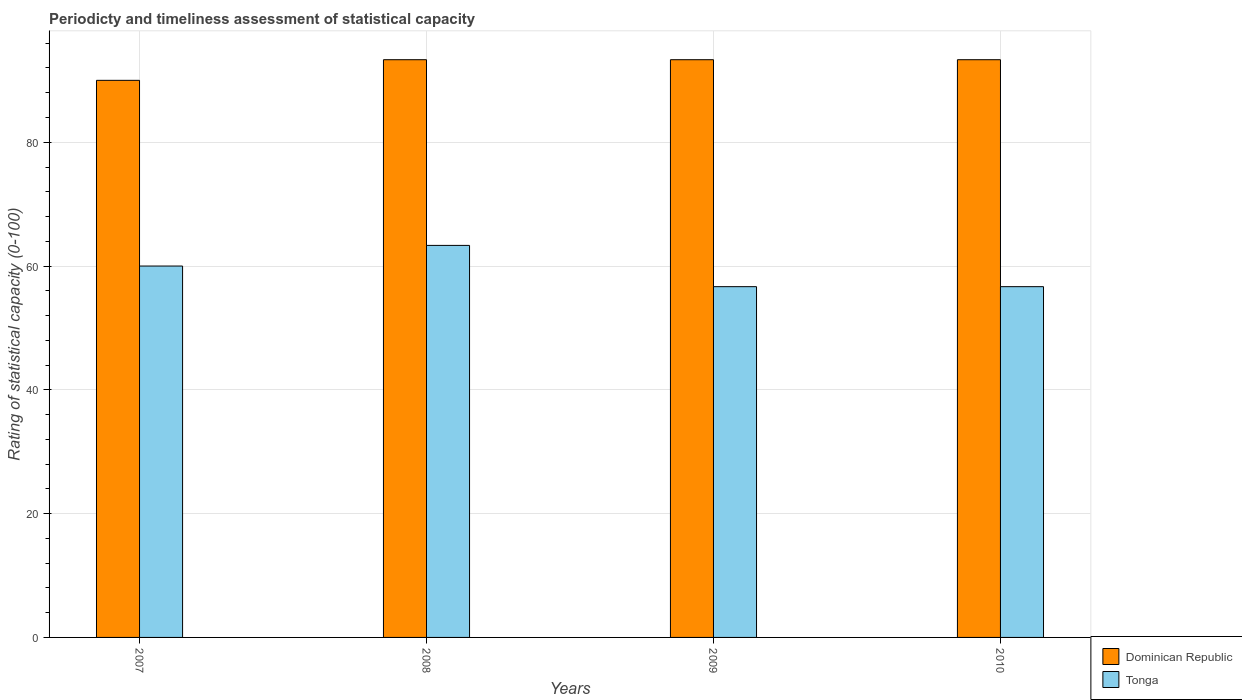How many bars are there on the 1st tick from the left?
Give a very brief answer. 2. How many bars are there on the 2nd tick from the right?
Make the answer very short. 2. What is the label of the 2nd group of bars from the left?
Your response must be concise. 2008. In how many cases, is the number of bars for a given year not equal to the number of legend labels?
Make the answer very short. 0. What is the rating of statistical capacity in Dominican Republic in 2010?
Your answer should be very brief. 93.33. Across all years, what is the maximum rating of statistical capacity in Tonga?
Give a very brief answer. 63.33. Across all years, what is the minimum rating of statistical capacity in Dominican Republic?
Offer a very short reply. 90. In which year was the rating of statistical capacity in Tonga minimum?
Your response must be concise. 2009. What is the total rating of statistical capacity in Tonga in the graph?
Keep it short and to the point. 236.67. What is the difference between the rating of statistical capacity in Tonga in 2007 and that in 2009?
Give a very brief answer. 3.33. What is the difference between the rating of statistical capacity in Tonga in 2008 and the rating of statistical capacity in Dominican Republic in 2010?
Give a very brief answer. -30. What is the average rating of statistical capacity in Dominican Republic per year?
Make the answer very short. 92.5. In the year 2007, what is the difference between the rating of statistical capacity in Tonga and rating of statistical capacity in Dominican Republic?
Give a very brief answer. -30. What is the ratio of the rating of statistical capacity in Dominican Republic in 2007 to that in 2009?
Ensure brevity in your answer.  0.96. Is the difference between the rating of statistical capacity in Tonga in 2009 and 2010 greater than the difference between the rating of statistical capacity in Dominican Republic in 2009 and 2010?
Provide a short and direct response. No. What is the difference between the highest and the second highest rating of statistical capacity in Tonga?
Provide a short and direct response. 3.33. What is the difference between the highest and the lowest rating of statistical capacity in Tonga?
Your answer should be very brief. 6.67. In how many years, is the rating of statistical capacity in Dominican Republic greater than the average rating of statistical capacity in Dominican Republic taken over all years?
Give a very brief answer. 3. Is the sum of the rating of statistical capacity in Dominican Republic in 2007 and 2008 greater than the maximum rating of statistical capacity in Tonga across all years?
Give a very brief answer. Yes. What does the 2nd bar from the left in 2008 represents?
Give a very brief answer. Tonga. What does the 1st bar from the right in 2007 represents?
Give a very brief answer. Tonga. How many bars are there?
Your answer should be very brief. 8. Does the graph contain any zero values?
Give a very brief answer. No. How many legend labels are there?
Offer a terse response. 2. How are the legend labels stacked?
Provide a short and direct response. Vertical. What is the title of the graph?
Keep it short and to the point. Periodicty and timeliness assessment of statistical capacity. What is the label or title of the X-axis?
Give a very brief answer. Years. What is the label or title of the Y-axis?
Your answer should be compact. Rating of statistical capacity (0-100). What is the Rating of statistical capacity (0-100) of Dominican Republic in 2008?
Provide a succinct answer. 93.33. What is the Rating of statistical capacity (0-100) in Tonga in 2008?
Give a very brief answer. 63.33. What is the Rating of statistical capacity (0-100) in Dominican Republic in 2009?
Make the answer very short. 93.33. What is the Rating of statistical capacity (0-100) of Tonga in 2009?
Give a very brief answer. 56.67. What is the Rating of statistical capacity (0-100) of Dominican Republic in 2010?
Your response must be concise. 93.33. What is the Rating of statistical capacity (0-100) in Tonga in 2010?
Offer a terse response. 56.67. Across all years, what is the maximum Rating of statistical capacity (0-100) of Dominican Republic?
Give a very brief answer. 93.33. Across all years, what is the maximum Rating of statistical capacity (0-100) of Tonga?
Provide a succinct answer. 63.33. Across all years, what is the minimum Rating of statistical capacity (0-100) of Tonga?
Your response must be concise. 56.67. What is the total Rating of statistical capacity (0-100) of Dominican Republic in the graph?
Offer a very short reply. 370. What is the total Rating of statistical capacity (0-100) of Tonga in the graph?
Keep it short and to the point. 236.67. What is the difference between the Rating of statistical capacity (0-100) in Dominican Republic in 2007 and that in 2008?
Your response must be concise. -3.33. What is the difference between the Rating of statistical capacity (0-100) of Tonga in 2008 and that in 2009?
Ensure brevity in your answer.  6.67. What is the difference between the Rating of statistical capacity (0-100) in Dominican Republic in 2008 and that in 2010?
Your answer should be compact. 0. What is the difference between the Rating of statistical capacity (0-100) in Tonga in 2008 and that in 2010?
Provide a succinct answer. 6.67. What is the difference between the Rating of statistical capacity (0-100) of Dominican Republic in 2009 and that in 2010?
Provide a succinct answer. 0. What is the difference between the Rating of statistical capacity (0-100) of Tonga in 2009 and that in 2010?
Ensure brevity in your answer.  0. What is the difference between the Rating of statistical capacity (0-100) of Dominican Republic in 2007 and the Rating of statistical capacity (0-100) of Tonga in 2008?
Your answer should be very brief. 26.67. What is the difference between the Rating of statistical capacity (0-100) of Dominican Republic in 2007 and the Rating of statistical capacity (0-100) of Tonga in 2009?
Your answer should be compact. 33.33. What is the difference between the Rating of statistical capacity (0-100) in Dominican Republic in 2007 and the Rating of statistical capacity (0-100) in Tonga in 2010?
Provide a short and direct response. 33.33. What is the difference between the Rating of statistical capacity (0-100) in Dominican Republic in 2008 and the Rating of statistical capacity (0-100) in Tonga in 2009?
Keep it short and to the point. 36.67. What is the difference between the Rating of statistical capacity (0-100) of Dominican Republic in 2008 and the Rating of statistical capacity (0-100) of Tonga in 2010?
Keep it short and to the point. 36.67. What is the difference between the Rating of statistical capacity (0-100) in Dominican Republic in 2009 and the Rating of statistical capacity (0-100) in Tonga in 2010?
Offer a very short reply. 36.67. What is the average Rating of statistical capacity (0-100) in Dominican Republic per year?
Your response must be concise. 92.5. What is the average Rating of statistical capacity (0-100) of Tonga per year?
Provide a short and direct response. 59.17. In the year 2007, what is the difference between the Rating of statistical capacity (0-100) of Dominican Republic and Rating of statistical capacity (0-100) of Tonga?
Offer a very short reply. 30. In the year 2009, what is the difference between the Rating of statistical capacity (0-100) in Dominican Republic and Rating of statistical capacity (0-100) in Tonga?
Provide a short and direct response. 36.67. In the year 2010, what is the difference between the Rating of statistical capacity (0-100) in Dominican Republic and Rating of statistical capacity (0-100) in Tonga?
Provide a short and direct response. 36.67. What is the ratio of the Rating of statistical capacity (0-100) of Dominican Republic in 2007 to that in 2008?
Your response must be concise. 0.96. What is the ratio of the Rating of statistical capacity (0-100) in Tonga in 2007 to that in 2009?
Provide a succinct answer. 1.06. What is the ratio of the Rating of statistical capacity (0-100) in Tonga in 2007 to that in 2010?
Make the answer very short. 1.06. What is the ratio of the Rating of statistical capacity (0-100) in Dominican Republic in 2008 to that in 2009?
Offer a terse response. 1. What is the ratio of the Rating of statistical capacity (0-100) of Tonga in 2008 to that in 2009?
Give a very brief answer. 1.12. What is the ratio of the Rating of statistical capacity (0-100) in Dominican Republic in 2008 to that in 2010?
Ensure brevity in your answer.  1. What is the ratio of the Rating of statistical capacity (0-100) of Tonga in 2008 to that in 2010?
Give a very brief answer. 1.12. 